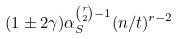<formula> <loc_0><loc_0><loc_500><loc_500>( 1 \pm 2 \gamma ) \alpha _ { S } ^ { \binom { r } { 2 } - 1 } ( n / t ) ^ { r - 2 }</formula> 